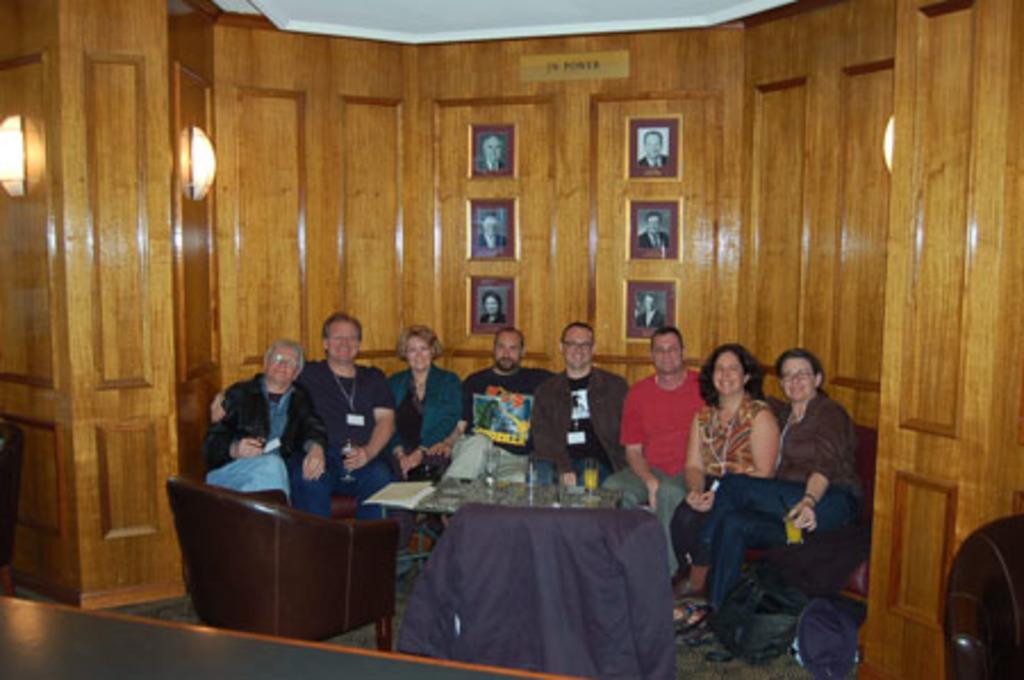How would you summarize this image in a sentence or two? In this image there are group of persons who are sitting on the chair and at the foreground of the image there is a table on which there are some objects and at the background of the image there is a cupboard and paintings. 